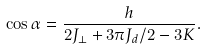<formula> <loc_0><loc_0><loc_500><loc_500>\cos { \alpha } = \frac { h } { 2 J _ { \perp } + 3 \pi J _ { d } / 2 - 3 K } .</formula> 